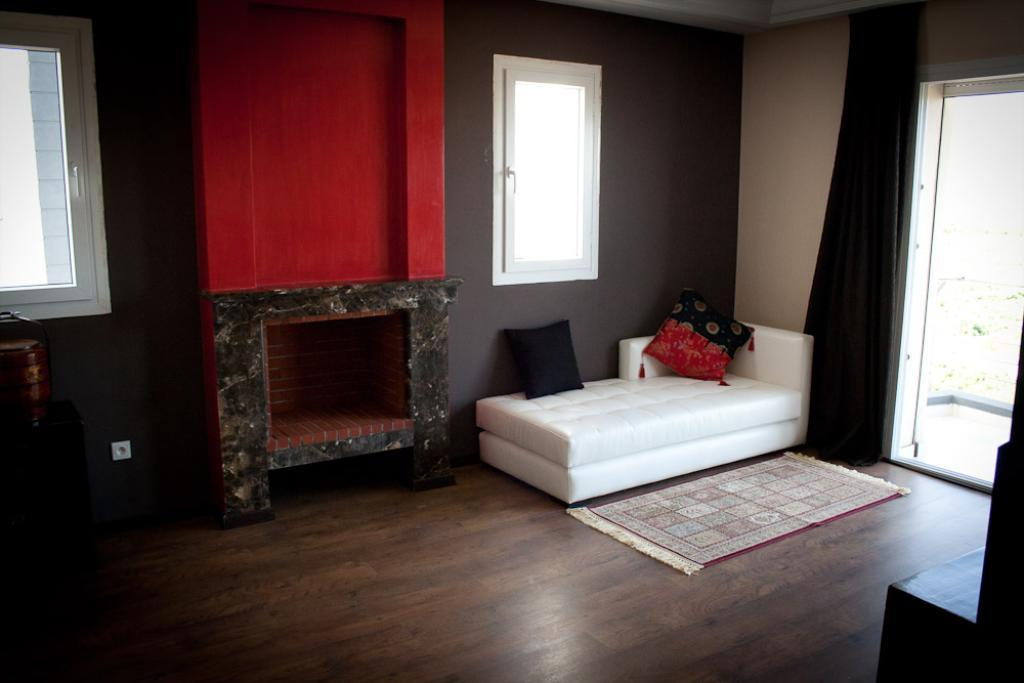What type of space is depicted in the image? The image shows an inner view of a room. What type of window treatment is present in the room? There is a curtain in the room. How many windows are visible in the room? There are multiple windows in the room. What type of furniture is in the room? There is a sofa bed in the room. What is placed on the sofa bed? There are cushions on the sofa bed. What is on the floor in the room? There is a mat on the floor. What type of truck can be seen driving through the room in the image? There is no truck present in the image; it depicts an inner view of a room with no vehicles. 